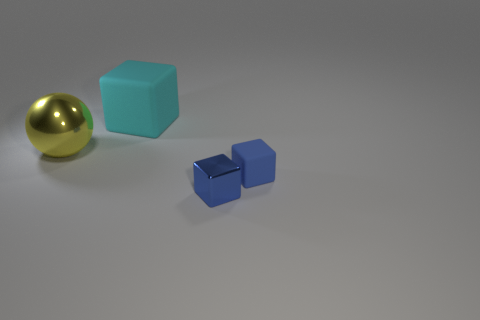Add 4 large cyan metallic things. How many objects exist? 8 Subtract all cubes. How many objects are left? 1 Add 3 metallic cubes. How many metallic cubes are left? 4 Add 4 small blue shiny blocks. How many small blue shiny blocks exist? 5 Subtract 0 gray cylinders. How many objects are left? 4 Subtract all large yellow matte things. Subtract all cubes. How many objects are left? 1 